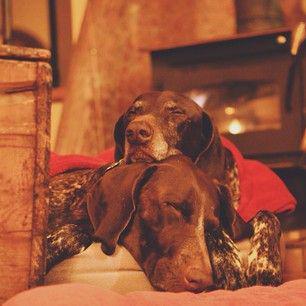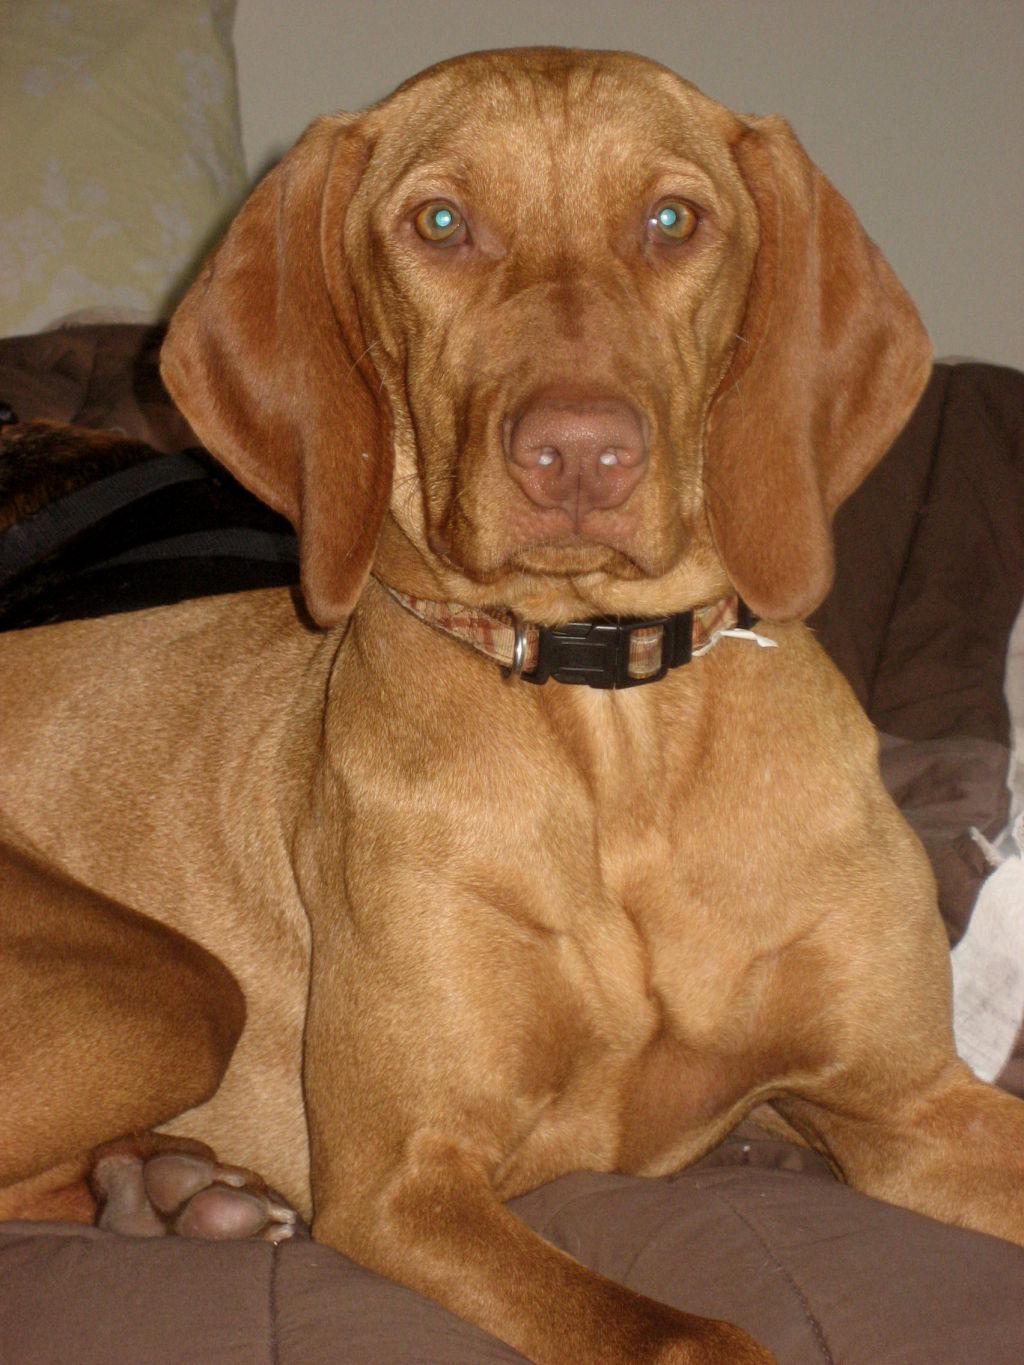The first image is the image on the left, the second image is the image on the right. Examine the images to the left and right. Is the description "Each image contains a single dog with floppy ears, and one image shows a dog outdoors in a non-reclining pose with its head and body angled rightward." accurate? Answer yes or no. No. 